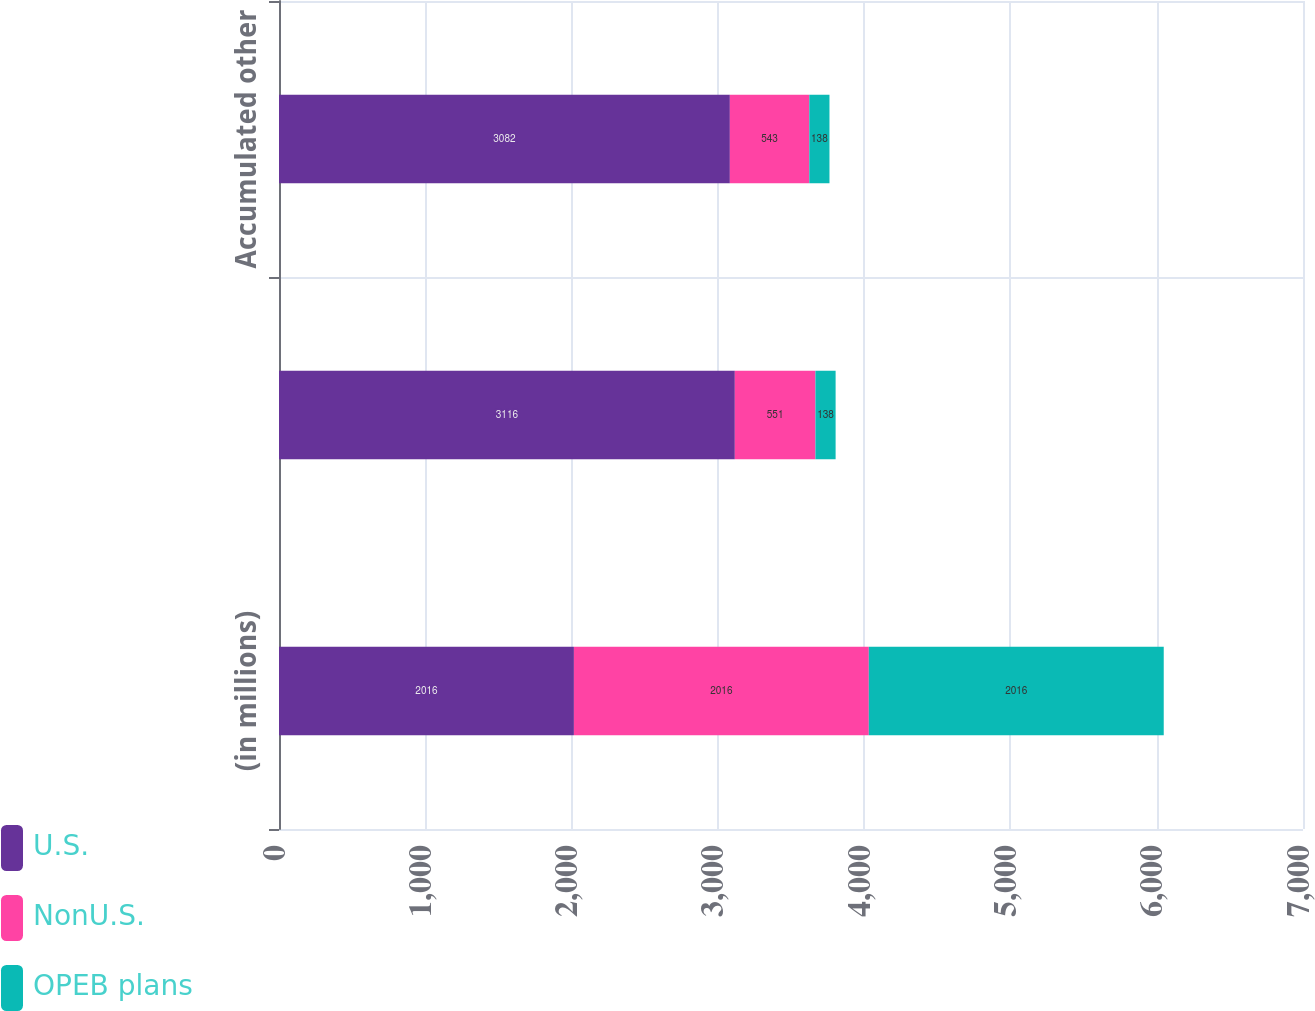Convert chart. <chart><loc_0><loc_0><loc_500><loc_500><stacked_bar_chart><ecel><fcel>(in millions)<fcel>Net gain/(loss)<fcel>Accumulated other<nl><fcel>U.S.<fcel>2016<fcel>3116<fcel>3082<nl><fcel>NonU.S.<fcel>2016<fcel>551<fcel>543<nl><fcel>OPEB plans<fcel>2016<fcel>138<fcel>138<nl></chart> 